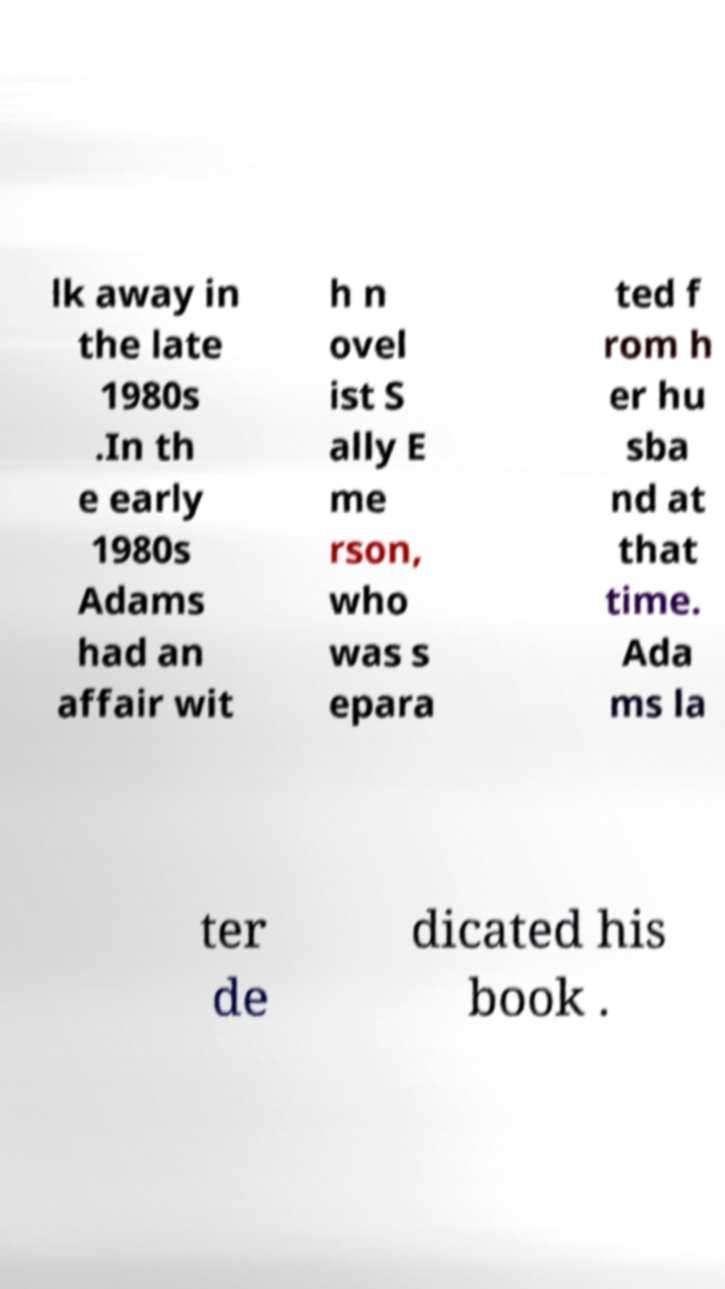I need the written content from this picture converted into text. Can you do that? lk away in the late 1980s .In th e early 1980s Adams had an affair wit h n ovel ist S ally E me rson, who was s epara ted f rom h er hu sba nd at that time. Ada ms la ter de dicated his book . 